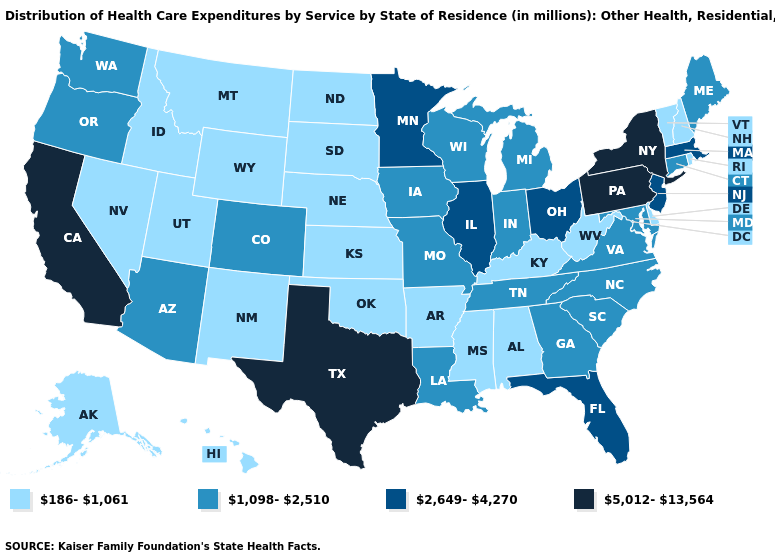Which states have the lowest value in the USA?
Quick response, please. Alabama, Alaska, Arkansas, Delaware, Hawaii, Idaho, Kansas, Kentucky, Mississippi, Montana, Nebraska, Nevada, New Hampshire, New Mexico, North Dakota, Oklahoma, Rhode Island, South Dakota, Utah, Vermont, West Virginia, Wyoming. Among the states that border Virginia , which have the lowest value?
Quick response, please. Kentucky, West Virginia. Does Florida have the highest value in the USA?
Give a very brief answer. No. Name the states that have a value in the range 2,649-4,270?
Concise answer only. Florida, Illinois, Massachusetts, Minnesota, New Jersey, Ohio. Name the states that have a value in the range 186-1,061?
Concise answer only. Alabama, Alaska, Arkansas, Delaware, Hawaii, Idaho, Kansas, Kentucky, Mississippi, Montana, Nebraska, Nevada, New Hampshire, New Mexico, North Dakota, Oklahoma, Rhode Island, South Dakota, Utah, Vermont, West Virginia, Wyoming. Name the states that have a value in the range 186-1,061?
Answer briefly. Alabama, Alaska, Arkansas, Delaware, Hawaii, Idaho, Kansas, Kentucky, Mississippi, Montana, Nebraska, Nevada, New Hampshire, New Mexico, North Dakota, Oklahoma, Rhode Island, South Dakota, Utah, Vermont, West Virginia, Wyoming. What is the value of Georgia?
Answer briefly. 1,098-2,510. What is the value of Ohio?
Write a very short answer. 2,649-4,270. Among the states that border Idaho , which have the highest value?
Answer briefly. Oregon, Washington. Name the states that have a value in the range 186-1,061?
Concise answer only. Alabama, Alaska, Arkansas, Delaware, Hawaii, Idaho, Kansas, Kentucky, Mississippi, Montana, Nebraska, Nevada, New Hampshire, New Mexico, North Dakota, Oklahoma, Rhode Island, South Dakota, Utah, Vermont, West Virginia, Wyoming. What is the value of Georgia?
Write a very short answer. 1,098-2,510. What is the value of North Carolina?
Quick response, please. 1,098-2,510. What is the highest value in the South ?
Concise answer only. 5,012-13,564. Does Oklahoma have the lowest value in the USA?
Answer briefly. Yes. Name the states that have a value in the range 5,012-13,564?
Keep it brief. California, New York, Pennsylvania, Texas. 